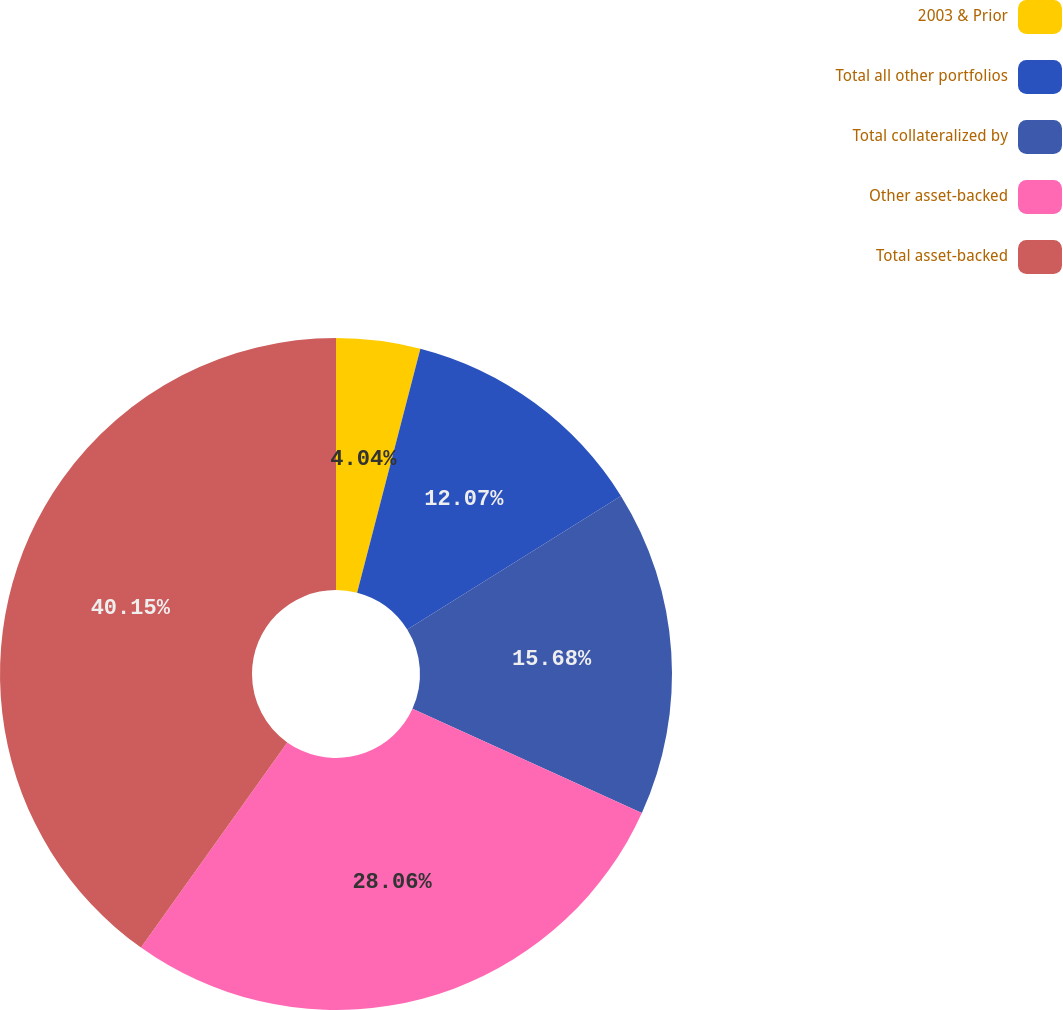<chart> <loc_0><loc_0><loc_500><loc_500><pie_chart><fcel>2003 & Prior<fcel>Total all other portfolios<fcel>Total collateralized by<fcel>Other asset-backed<fcel>Total asset-backed<nl><fcel>4.04%<fcel>12.07%<fcel>15.68%<fcel>28.06%<fcel>40.14%<nl></chart> 